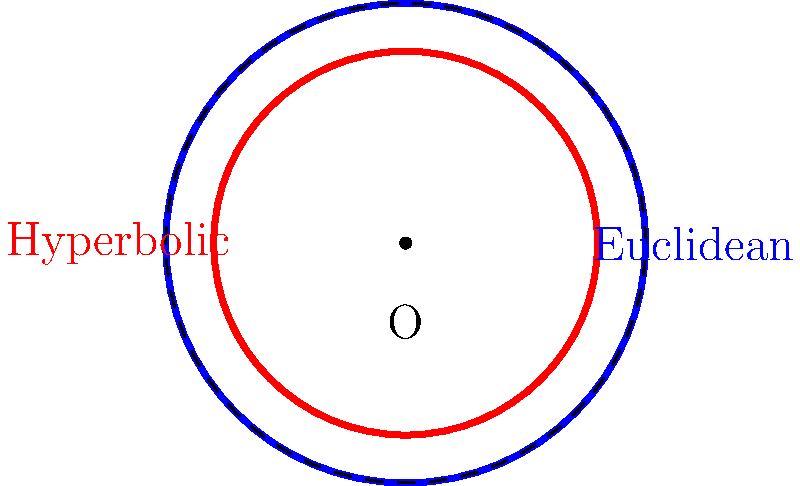In the Poincaré disk model of hyperbolic geometry, a circle with radius $r$ in hyperbolic space appears smaller than a Euclidean circle with the same radius when projected onto the disk. If the area of the blue Euclidean circle is $\pi$ square units, what is the area of the red hyperbolic circle in hyperbolic geometry, assuming it has the same hyperbolic radius as the Euclidean circle? To solve this problem, we need to follow these steps:

1) In Euclidean geometry, the area of a circle is given by $A_E = \pi r^2$. We're told that the area of the Euclidean circle is $\pi$, so $r = 1$ in Euclidean units.

2) In hyperbolic geometry, the area of a circle is given by:

   $A_H = 4\pi \sinh^2(\frac{r}{2})$

   where $r$ is the hyperbolic radius.

3) We're told that the hyperbolic circle has the same hyperbolic radius as the Euclidean circle's Euclidean radius. So, $r = 1$ in hyperbolic units as well.

4) Now we can calculate the area of the hyperbolic circle:

   $A_H = 4\pi \sinh^2(\frac{1}{2})$

5) Using a calculator or hyperbolic function tables:

   $\sinh(\frac{1}{2}) \approx 0.5211$

6) Therefore:

   $A_H = 4\pi (0.5211)^2 \approx 3.4162$

Thus, despite appearing smaller in the Poincaré disk model, the hyperbolic circle actually has a larger area in hyperbolic geometry than the Euclidean circle does in Euclidean geometry.

This counterintuitive result highlights how spatial relationships differ in non-Euclidean geometries, emphasizing the importance of clear communication and understanding different perspectives, much like in sibling conflicts.
Answer: $4\pi \sinh^2(\frac{1}{2}) \approx 3.4162$ square units 